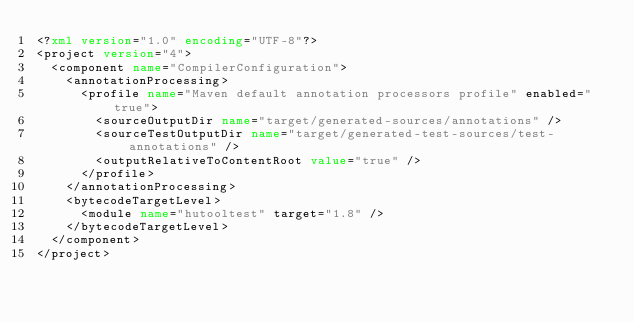<code> <loc_0><loc_0><loc_500><loc_500><_XML_><?xml version="1.0" encoding="UTF-8"?>
<project version="4">
  <component name="CompilerConfiguration">
    <annotationProcessing>
      <profile name="Maven default annotation processors profile" enabled="true">
        <sourceOutputDir name="target/generated-sources/annotations" />
        <sourceTestOutputDir name="target/generated-test-sources/test-annotations" />
        <outputRelativeToContentRoot value="true" />
      </profile>
    </annotationProcessing>
    <bytecodeTargetLevel>
      <module name="hutooltest" target="1.8" />
    </bytecodeTargetLevel>
  </component>
</project></code> 